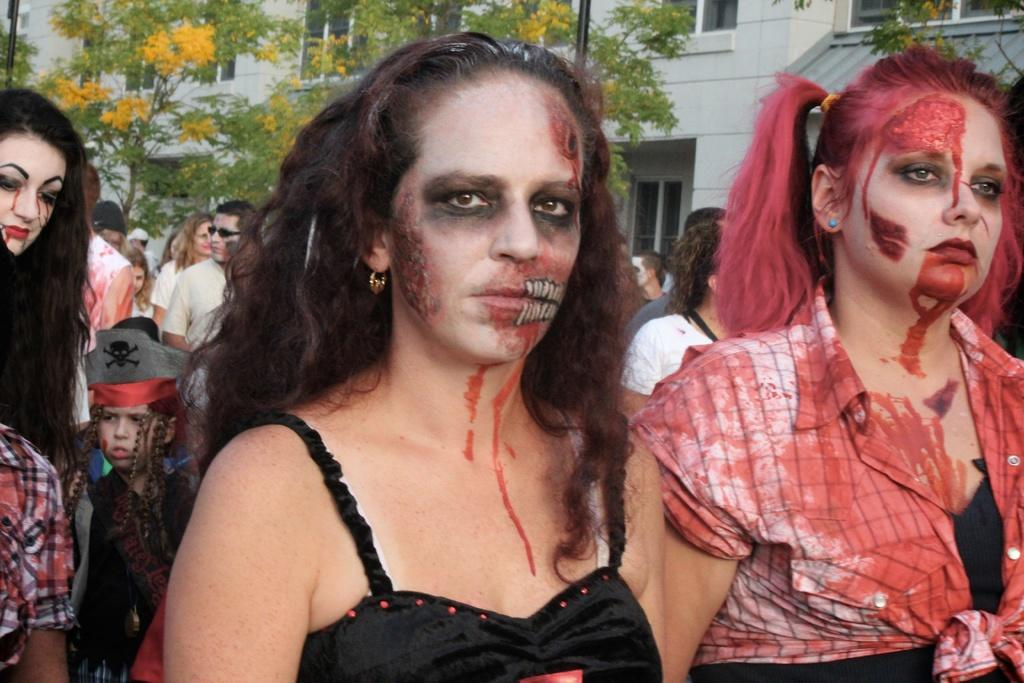How many people are in the image? There are two girls in the image. What are the girls wearing? The girls are dressed for Halloween. What can be seen in the background of the image? There are trees and buildings visible in the background of the image. Can you see a mitten on the ground in the image? There is no mitten visible on the ground in the image. What does the mom of the girls look like in the image? There is no mom present in the image; only the two girls are visible. 